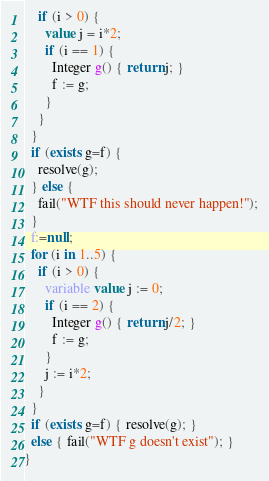Convert code to text. <code><loc_0><loc_0><loc_500><loc_500><_Ceylon_>    if (i > 0) {
      value j = i*2;
      if (i == 1) {
        Integer g() { return j; }
        f := g;
      }
    }
  }
  if (exists g=f) {
    resolve(g);
  } else {
    fail("WTF this should never happen!");
  }
  f:=null;
  for (i in 1..5) {
    if (i > 0) {
      variable value j := 0;
      if (i == 2) {
        Integer g() { return j/2; }
        f := g;
      }
      j := i*2;
    }
  }
  if (exists g=f) { resolve(g); }
  else { fail("WTF g doesn't exist"); }
}
</code> 